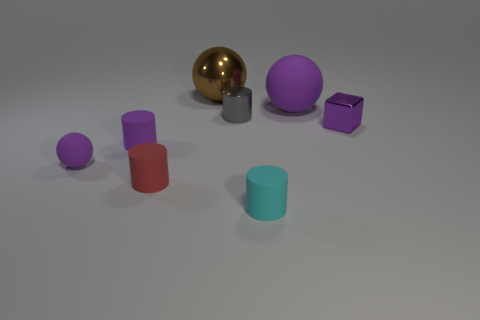Add 2 large yellow metallic things. How many objects exist? 10 Subtract all cubes. How many objects are left? 7 Subtract all purple rubber objects. Subtract all tiny gray things. How many objects are left? 4 Add 7 big purple matte things. How many big purple matte things are left? 8 Add 6 big purple rubber balls. How many big purple rubber balls exist? 7 Subtract 0 blue balls. How many objects are left? 8 